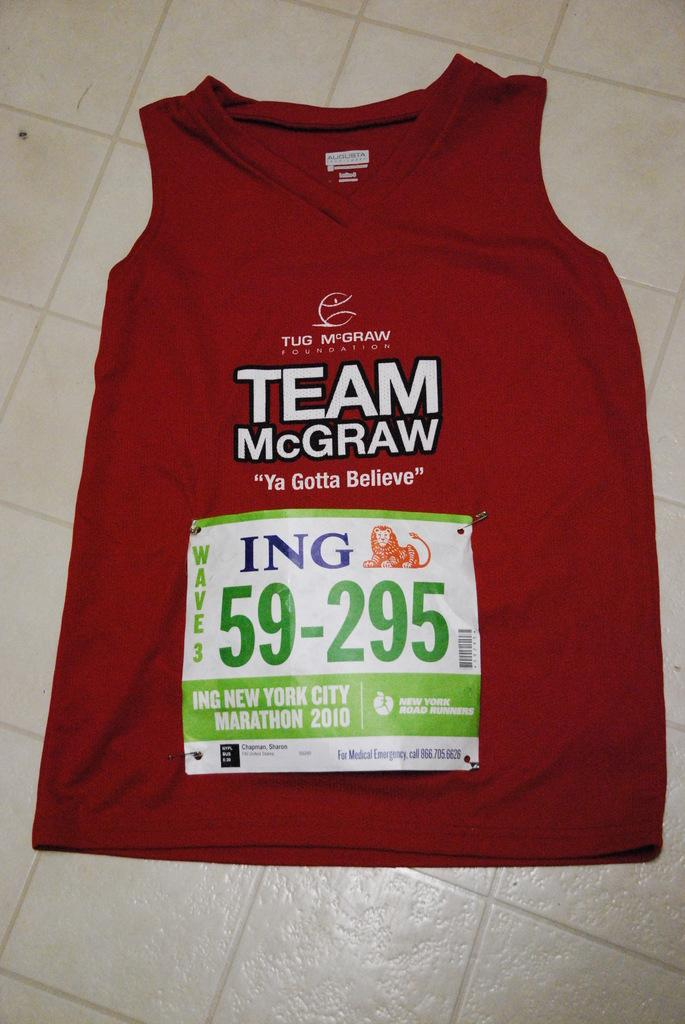<image>
Write a terse but informative summary of the picture. a red tanktop that says 'team mcgraw' on it 